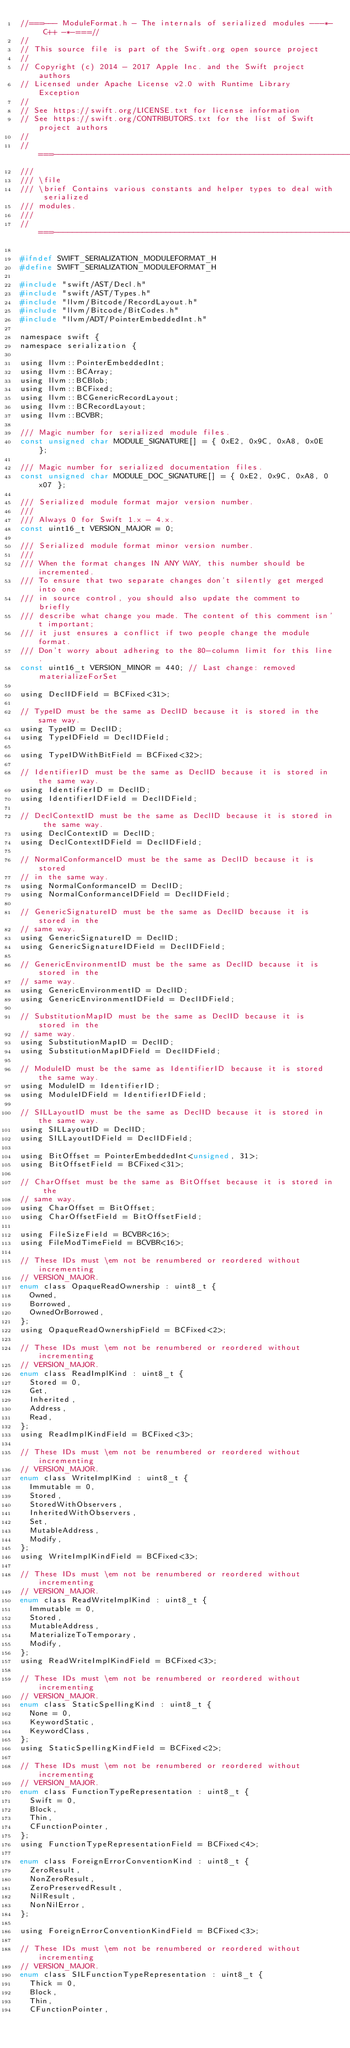<code> <loc_0><loc_0><loc_500><loc_500><_C_>//===--- ModuleFormat.h - The internals of serialized modules ---*- C++ -*-===//
//
// This source file is part of the Swift.org open source project
//
// Copyright (c) 2014 - 2017 Apple Inc. and the Swift project authors
// Licensed under Apache License v2.0 with Runtime Library Exception
//
// See https://swift.org/LICENSE.txt for license information
// See https://swift.org/CONTRIBUTORS.txt for the list of Swift project authors
//
//===----------------------------------------------------------------------===//
///
/// \file
/// \brief Contains various constants and helper types to deal with serialized
/// modules.
///
//===----------------------------------------------------------------------===//

#ifndef SWIFT_SERIALIZATION_MODULEFORMAT_H
#define SWIFT_SERIALIZATION_MODULEFORMAT_H

#include "swift/AST/Decl.h"
#include "swift/AST/Types.h"
#include "llvm/Bitcode/RecordLayout.h"
#include "llvm/Bitcode/BitCodes.h"
#include "llvm/ADT/PointerEmbeddedInt.h"

namespace swift {
namespace serialization {

using llvm::PointerEmbeddedInt;
using llvm::BCArray;
using llvm::BCBlob;
using llvm::BCFixed;
using llvm::BCGenericRecordLayout;
using llvm::BCRecordLayout;
using llvm::BCVBR;

/// Magic number for serialized module files.
const unsigned char MODULE_SIGNATURE[] = { 0xE2, 0x9C, 0xA8, 0x0E };

/// Magic number for serialized documentation files.
const unsigned char MODULE_DOC_SIGNATURE[] = { 0xE2, 0x9C, 0xA8, 0x07 };

/// Serialized module format major version number.
///
/// Always 0 for Swift 1.x - 4.x.
const uint16_t VERSION_MAJOR = 0;

/// Serialized module format minor version number.
///
/// When the format changes IN ANY WAY, this number should be incremented.
/// To ensure that two separate changes don't silently get merged into one
/// in source control, you should also update the comment to briefly
/// describe what change you made. The content of this comment isn't important;
/// it just ensures a conflict if two people change the module format.
/// Don't worry about adhering to the 80-column limit for this line.
const uint16_t VERSION_MINOR = 440; // Last change: removed materializeForSet

using DeclIDField = BCFixed<31>;

// TypeID must be the same as DeclID because it is stored in the same way.
using TypeID = DeclID;
using TypeIDField = DeclIDField;

using TypeIDWithBitField = BCFixed<32>;

// IdentifierID must be the same as DeclID because it is stored in the same way.
using IdentifierID = DeclID;
using IdentifierIDField = DeclIDField;

// DeclContextID must be the same as DeclID because it is stored in the same way.
using DeclContextID = DeclID;
using DeclContextIDField = DeclIDField;

// NormalConformanceID must be the same as DeclID because it is stored
// in the same way.
using NormalConformanceID = DeclID;
using NormalConformanceIDField = DeclIDField;

// GenericSignatureID must be the same as DeclID because it is stored in the
// same way.
using GenericSignatureID = DeclID;
using GenericSignatureIDField = DeclIDField;

// GenericEnvironmentID must be the same as DeclID because it is stored in the
// same way.
using GenericEnvironmentID = DeclID;
using GenericEnvironmentIDField = DeclIDField;

// SubstitutionMapID must be the same as DeclID because it is stored in the
// same way.
using SubstitutionMapID = DeclID;
using SubstitutionMapIDField = DeclIDField;

// ModuleID must be the same as IdentifierID because it is stored the same way.
using ModuleID = IdentifierID;
using ModuleIDField = IdentifierIDField;

// SILLayoutID must be the same as DeclID because it is stored in the same way.
using SILLayoutID = DeclID;
using SILLayoutIDField = DeclIDField;

using BitOffset = PointerEmbeddedInt<unsigned, 31>;
using BitOffsetField = BCFixed<31>;

// CharOffset must be the same as BitOffset because it is stored in the
// same way.
using CharOffset = BitOffset;
using CharOffsetField = BitOffsetField;

using FileSizeField = BCVBR<16>;
using FileModTimeField = BCVBR<16>;

// These IDs must \em not be renumbered or reordered without incrementing
// VERSION_MAJOR.
enum class OpaqueReadOwnership : uint8_t {
  Owned,
  Borrowed,
  OwnedOrBorrowed,
};
using OpaqueReadOwnershipField = BCFixed<2>;

// These IDs must \em not be renumbered or reordered without incrementing
// VERSION_MAJOR.
enum class ReadImplKind : uint8_t {
  Stored = 0,
  Get,
  Inherited,
  Address,
  Read,
};
using ReadImplKindField = BCFixed<3>;

// These IDs must \em not be renumbered or reordered without incrementing
// VERSION_MAJOR.
enum class WriteImplKind : uint8_t {
  Immutable = 0,
  Stored,
  StoredWithObservers,
  InheritedWithObservers,
  Set,
  MutableAddress,
  Modify,
};
using WriteImplKindField = BCFixed<3>;

// These IDs must \em not be renumbered or reordered without incrementing
// VERSION_MAJOR.
enum class ReadWriteImplKind : uint8_t {
  Immutable = 0,
  Stored,
  MutableAddress,
  MaterializeToTemporary,
  Modify,
};
using ReadWriteImplKindField = BCFixed<3>;

// These IDs must \em not be renumbered or reordered without incrementing
// VERSION_MAJOR.
enum class StaticSpellingKind : uint8_t {
  None = 0,
  KeywordStatic,
  KeywordClass,
};
using StaticSpellingKindField = BCFixed<2>;

// These IDs must \em not be renumbered or reordered without incrementing
// VERSION_MAJOR.
enum class FunctionTypeRepresentation : uint8_t {
  Swift = 0,
  Block,
  Thin,
  CFunctionPointer,
};
using FunctionTypeRepresentationField = BCFixed<4>;

enum class ForeignErrorConventionKind : uint8_t {
  ZeroResult,
  NonZeroResult,
  ZeroPreservedResult,
  NilResult,
  NonNilError,
};

using ForeignErrorConventionKindField = BCFixed<3>;

// These IDs must \em not be renumbered or reordered without incrementing
// VERSION_MAJOR.
enum class SILFunctionTypeRepresentation : uint8_t {
  Thick = 0,
  Block,
  Thin,
  CFunctionPointer,
  </code> 